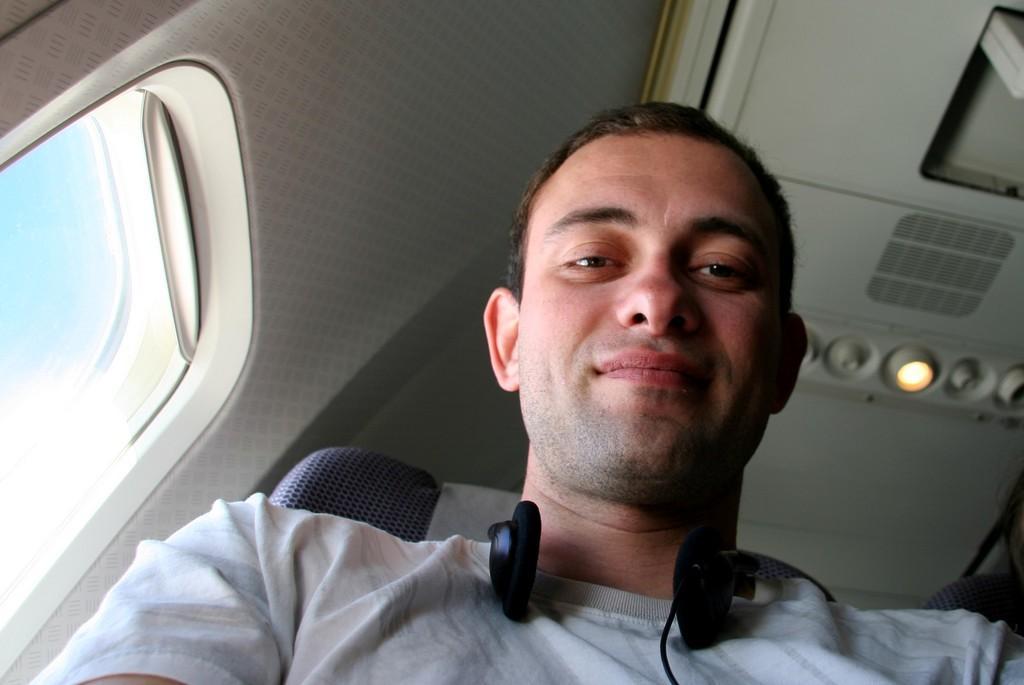Please provide a concise description of this image. In this image I can see a man is wearing headphones. The man is smiling. Here I can see a window. 